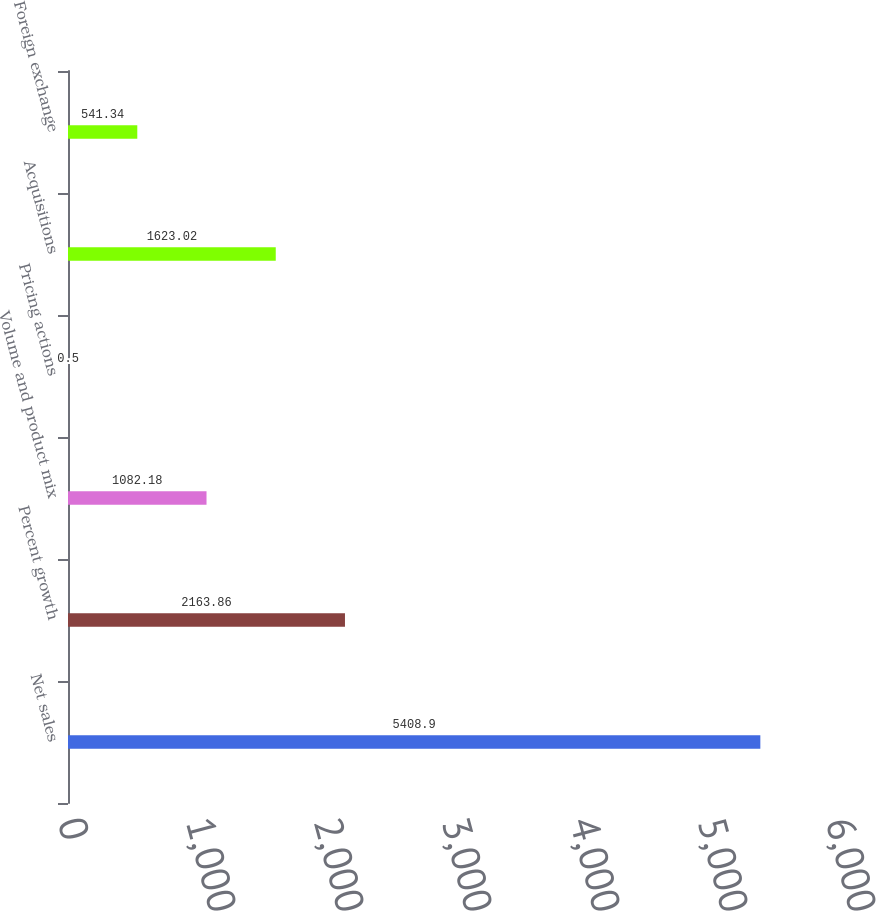<chart> <loc_0><loc_0><loc_500><loc_500><bar_chart><fcel>Net sales<fcel>Percent growth<fcel>Volume and product mix<fcel>Pricing actions<fcel>Acquisitions<fcel>Foreign exchange<nl><fcel>5408.9<fcel>2163.86<fcel>1082.18<fcel>0.5<fcel>1623.02<fcel>541.34<nl></chart> 